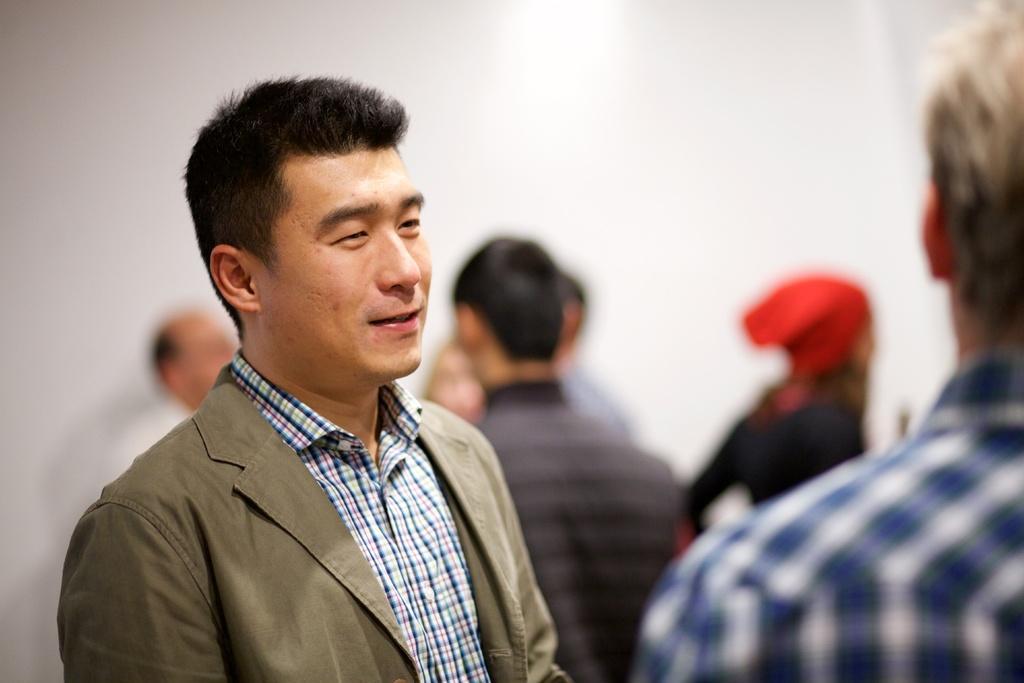Can you describe this image briefly? In this image there is a person standing and smiling , and in the background there are group of people , wall. 